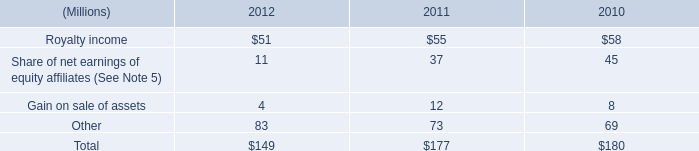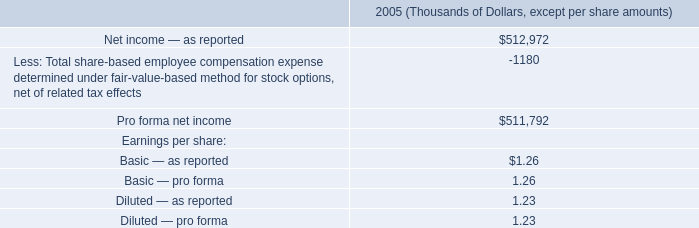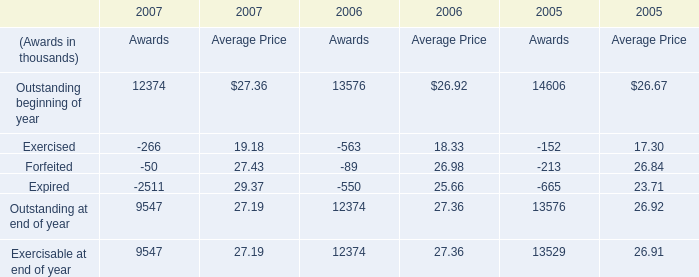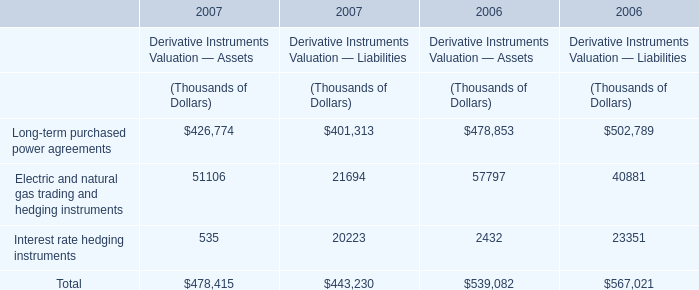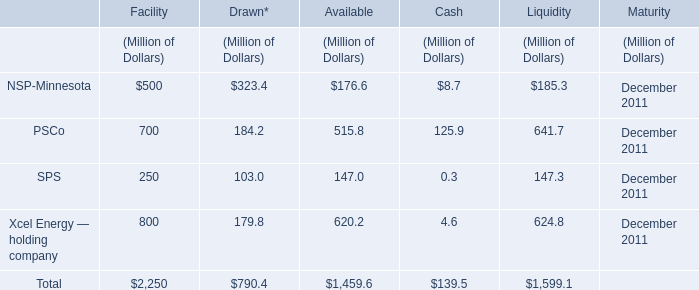what was the change in millions of total stock-based compensation cost from 2011 to 2012? 
Computations: (73 - 36)
Answer: 37.0. 